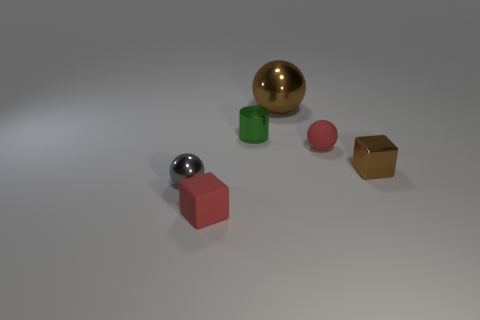Is the color of the small rubber block the same as the tiny cylinder? No, the color of the small rubber block which appears to be red is different from that of the tiny cylinder that has a green hue. 